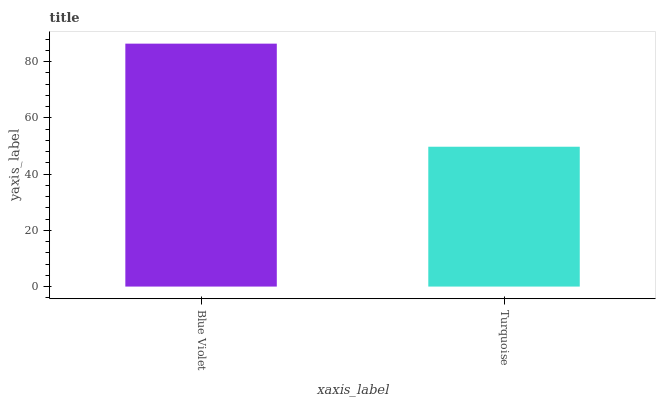Is Turquoise the minimum?
Answer yes or no. Yes. Is Blue Violet the maximum?
Answer yes or no. Yes. Is Turquoise the maximum?
Answer yes or no. No. Is Blue Violet greater than Turquoise?
Answer yes or no. Yes. Is Turquoise less than Blue Violet?
Answer yes or no. Yes. Is Turquoise greater than Blue Violet?
Answer yes or no. No. Is Blue Violet less than Turquoise?
Answer yes or no. No. Is Blue Violet the high median?
Answer yes or no. Yes. Is Turquoise the low median?
Answer yes or no. Yes. Is Turquoise the high median?
Answer yes or no. No. Is Blue Violet the low median?
Answer yes or no. No. 